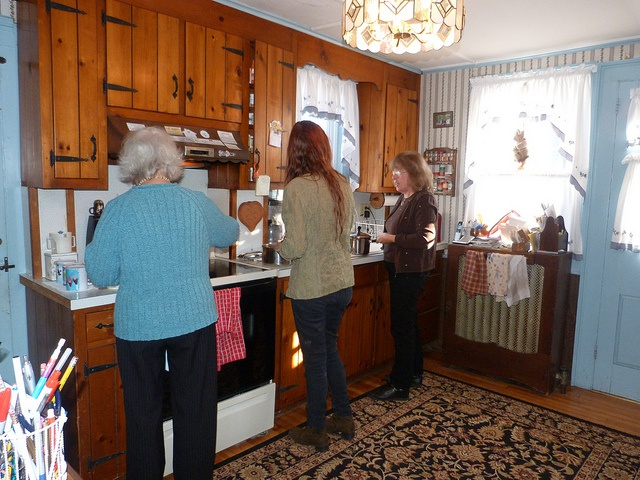Describe the objects in this image and their specific colors. I can see people in gray, teal, black, and darkgray tones, people in gray, black, and maroon tones, people in gray, black, maroon, and brown tones, oven in gray, black, darkgray, and brown tones, and cup in gray, lightblue, and darkgray tones in this image. 